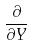<formula> <loc_0><loc_0><loc_500><loc_500>\frac { \partial } { \partial Y }</formula> 